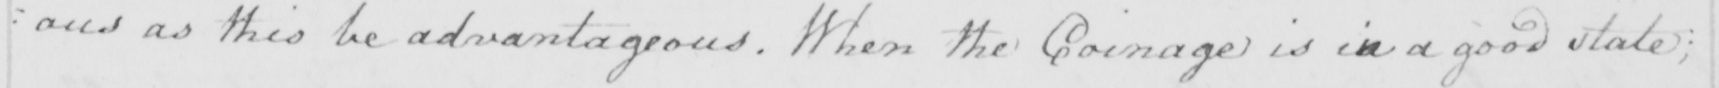What is written in this line of handwriting? : ous as this be advantageous . When the Coingage is in a good state ; 